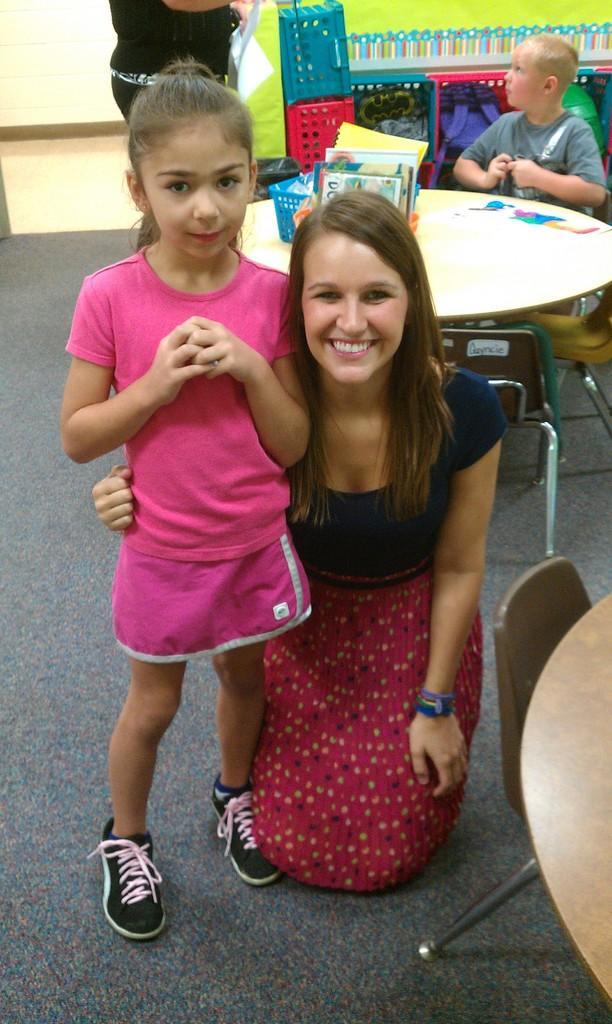Could you give a brief overview of what you see in this image? In this image there is a woman, there is a girl standing, there is a boy sitting on the chair, there are tables, there are objects on the tables, there are baskets, at the background of the image there is a wall. 